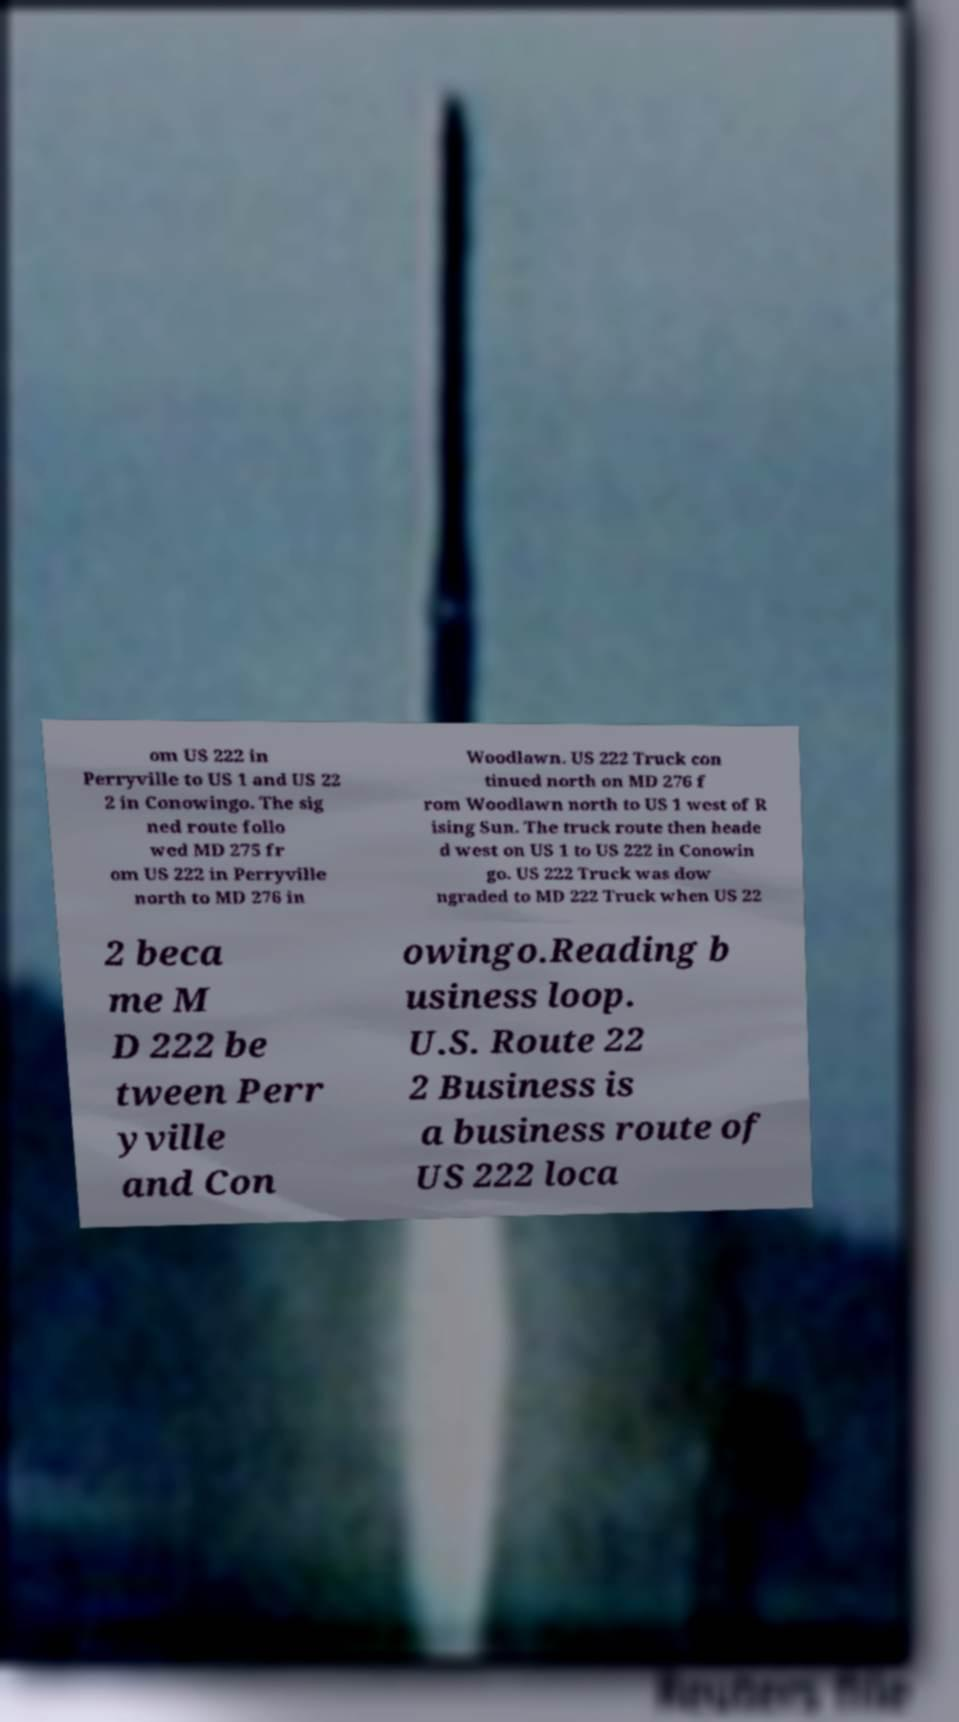Could you assist in decoding the text presented in this image and type it out clearly? om US 222 in Perryville to US 1 and US 22 2 in Conowingo. The sig ned route follo wed MD 275 fr om US 222 in Perryville north to MD 276 in Woodlawn. US 222 Truck con tinued north on MD 276 f rom Woodlawn north to US 1 west of R ising Sun. The truck route then heade d west on US 1 to US 222 in Conowin go. US 222 Truck was dow ngraded to MD 222 Truck when US 22 2 beca me M D 222 be tween Perr yville and Con owingo.Reading b usiness loop. U.S. Route 22 2 Business is a business route of US 222 loca 